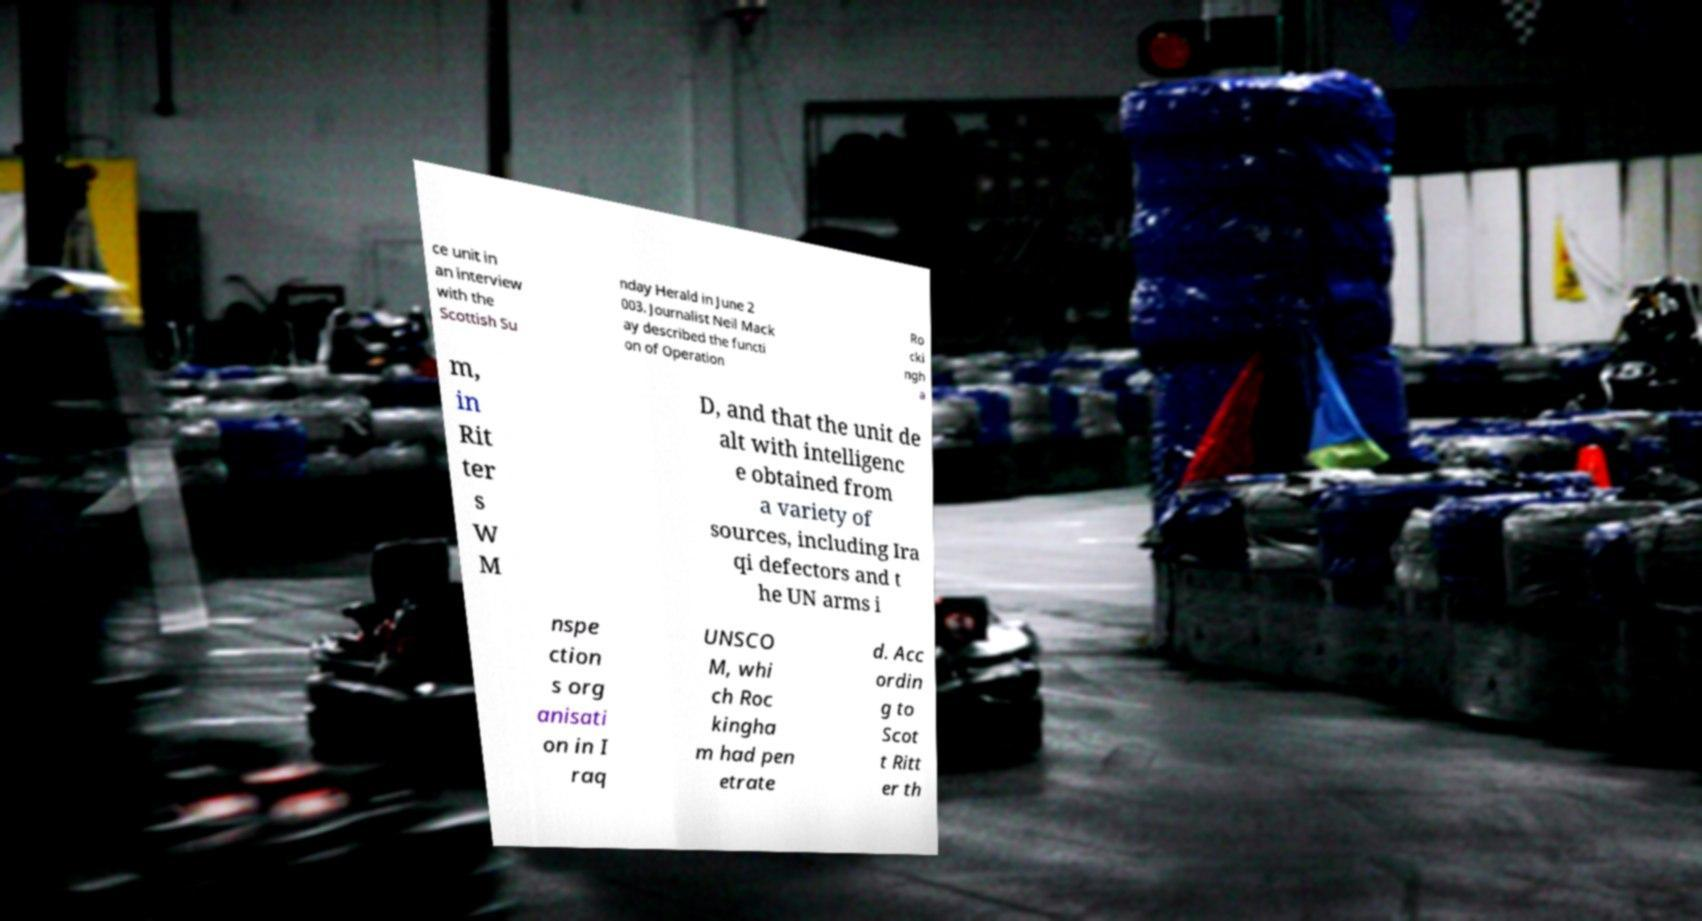Can you read and provide the text displayed in the image?This photo seems to have some interesting text. Can you extract and type it out for me? ce unit in an interview with the Scottish Su nday Herald in June 2 003. Journalist Neil Mack ay described the functi on of Operation Ro cki ngh a m, in Rit ter s W M D, and that the unit de alt with intelligenc e obtained from a variety of sources, including Ira qi defectors and t he UN arms i nspe ction s org anisati on in I raq UNSCO M, whi ch Roc kingha m had pen etrate d. Acc ordin g to Scot t Ritt er th 